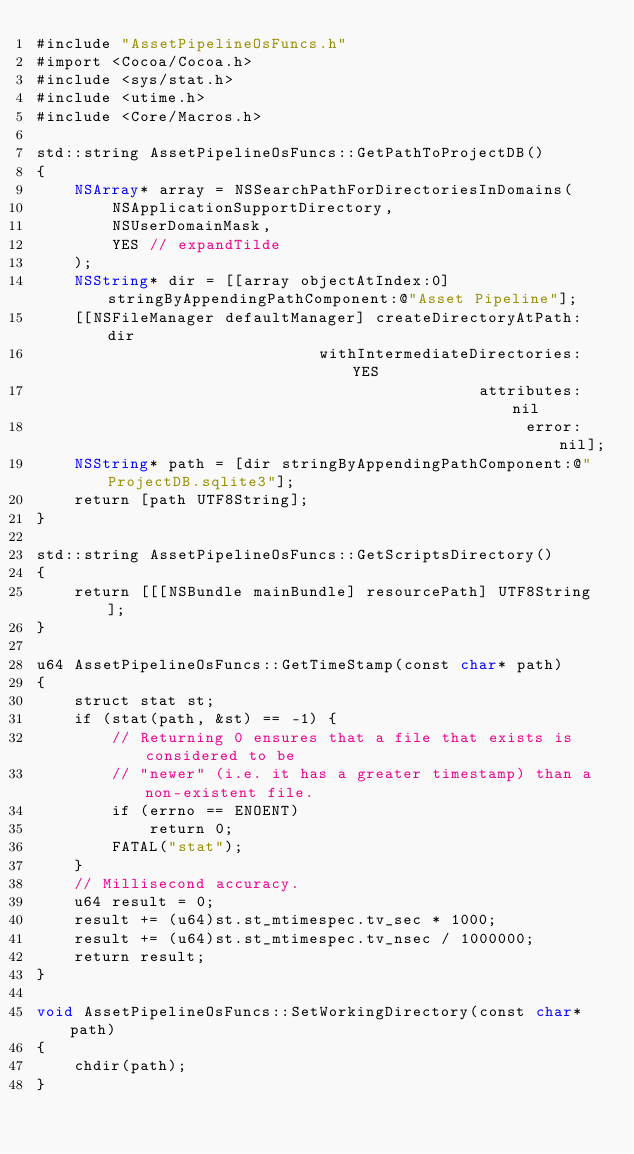<code> <loc_0><loc_0><loc_500><loc_500><_ObjectiveC_>#include "AssetPipelineOsFuncs.h"
#import <Cocoa/Cocoa.h>
#include <sys/stat.h>
#include <utime.h>
#include <Core/Macros.h>

std::string AssetPipelineOsFuncs::GetPathToProjectDB()
{
    NSArray* array = NSSearchPathForDirectoriesInDomains(
        NSApplicationSupportDirectory,
        NSUserDomainMask,
        YES // expandTilde
    );
    NSString* dir = [[array objectAtIndex:0] stringByAppendingPathComponent:@"Asset Pipeline"];
    [[NSFileManager defaultManager] createDirectoryAtPath:dir
                              withIntermediateDirectories:YES
                                               attributes:nil
                                                    error:nil];
    NSString* path = [dir stringByAppendingPathComponent:@"ProjectDB.sqlite3"];
    return [path UTF8String];
}

std::string AssetPipelineOsFuncs::GetScriptsDirectory()
{
    return [[[NSBundle mainBundle] resourcePath] UTF8String];
}

u64 AssetPipelineOsFuncs::GetTimeStamp(const char* path)
{
    struct stat st;
    if (stat(path, &st) == -1) {
        // Returning 0 ensures that a file that exists is considered to be
        // "newer" (i.e. it has a greater timestamp) than a non-existent file.
        if (errno == ENOENT)
            return 0;
        FATAL("stat");
    }
    // Millisecond accuracy.
    u64 result = 0;
    result += (u64)st.st_mtimespec.tv_sec * 1000;
    result += (u64)st.st_mtimespec.tv_nsec / 1000000;
    return result;
}

void AssetPipelineOsFuncs::SetWorkingDirectory(const char* path)
{
    chdir(path);
}
</code> 